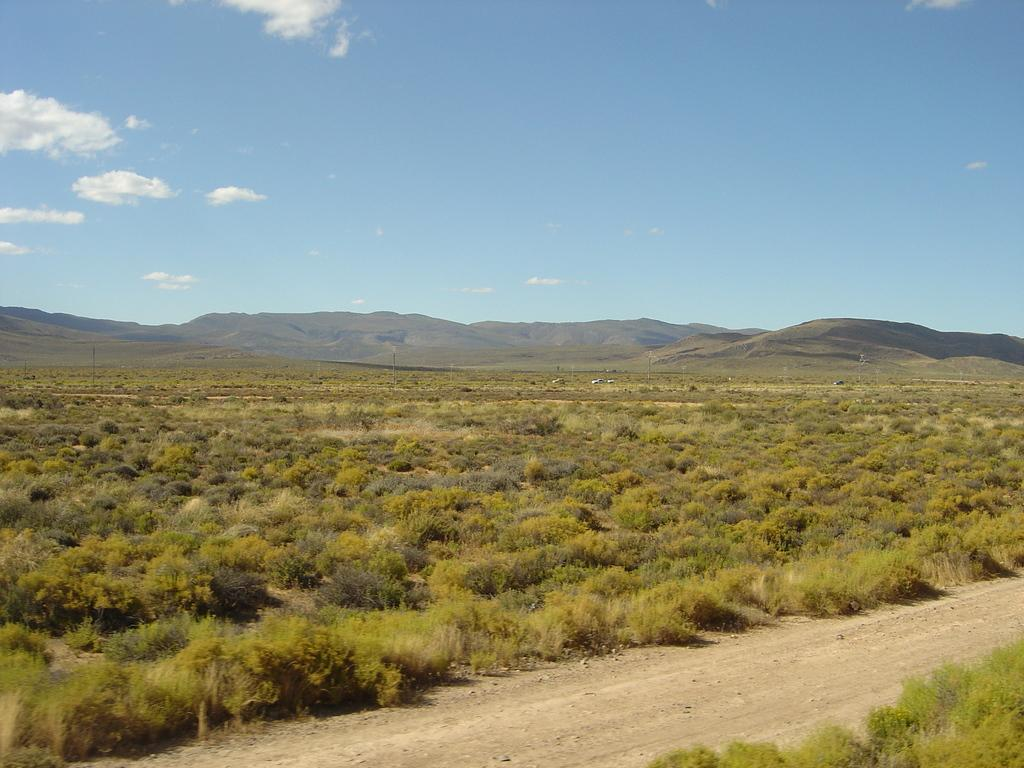What type of vegetation can be seen in the image? There is grass in the image. What is the surface beneath the grass? There is ground visible in the image. What can be seen in the distance in the image? There are mountains in the background of the image. What is visible above the mountains in the image? The sky is visible in the image. What is present in the sky in the image? Clouds are present in the sky. How many degrees does the boat need to turn in the image? There is no boat present in the image, so it is not possible to determine how many degrees it needs to turn. 